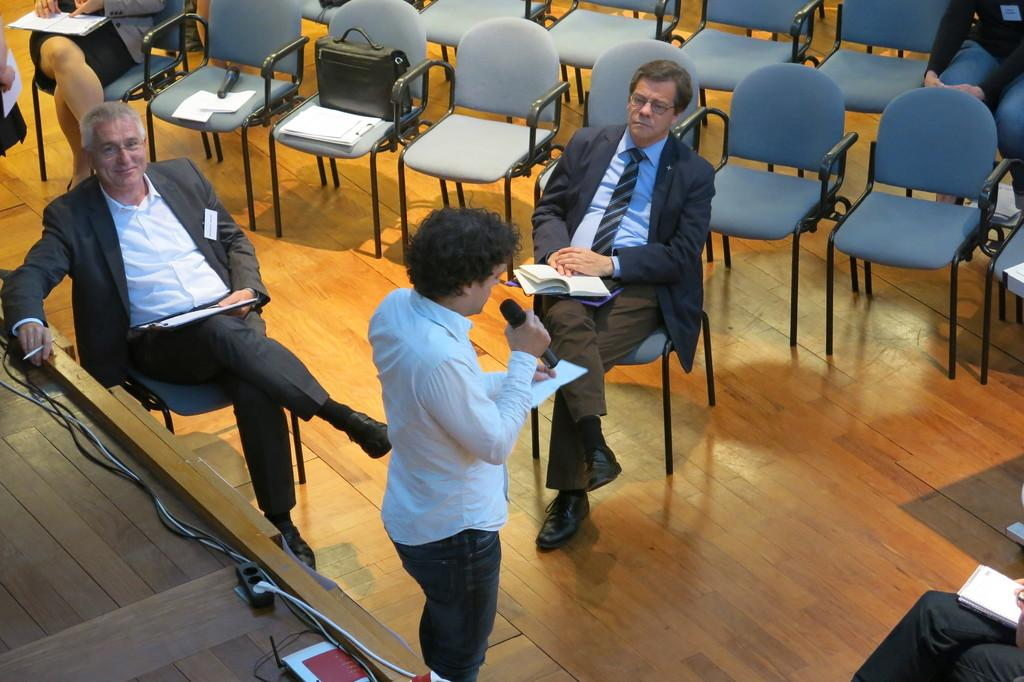What is happening in the image involving a group of people? There is a group of people sitting on chairs in the image. What are the people holding in their hands? The people have books in their hands in their hands. Can you describe the person in the middle of the group? The person in the middle is holding a microphone. What is the person in the middle doing with the microphone? The person in the middle is speaking into the microphone. What type of memory is being used by the person in the middle to store information? There is no information about memory usage in the image; it only shows a person holding a microphone and speaking. 